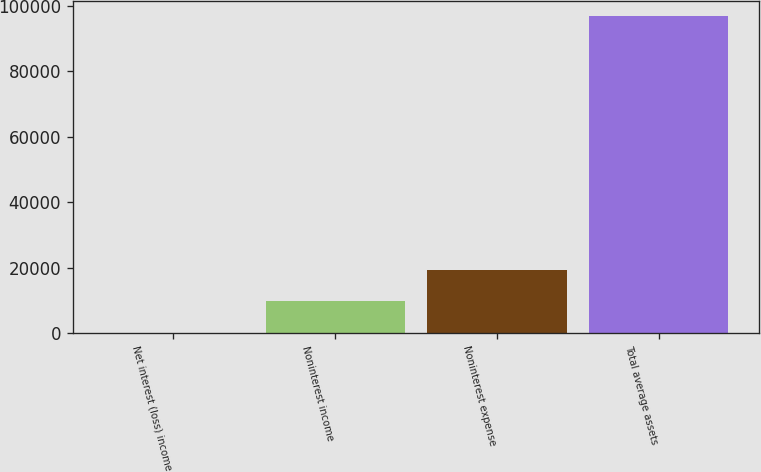<chart> <loc_0><loc_0><loc_500><loc_500><bar_chart><fcel>Net interest (loss) income<fcel>Noninterest income<fcel>Noninterest expense<fcel>Total average assets<nl><fcel>16<fcel>9687.6<fcel>19359.2<fcel>96732<nl></chart> 